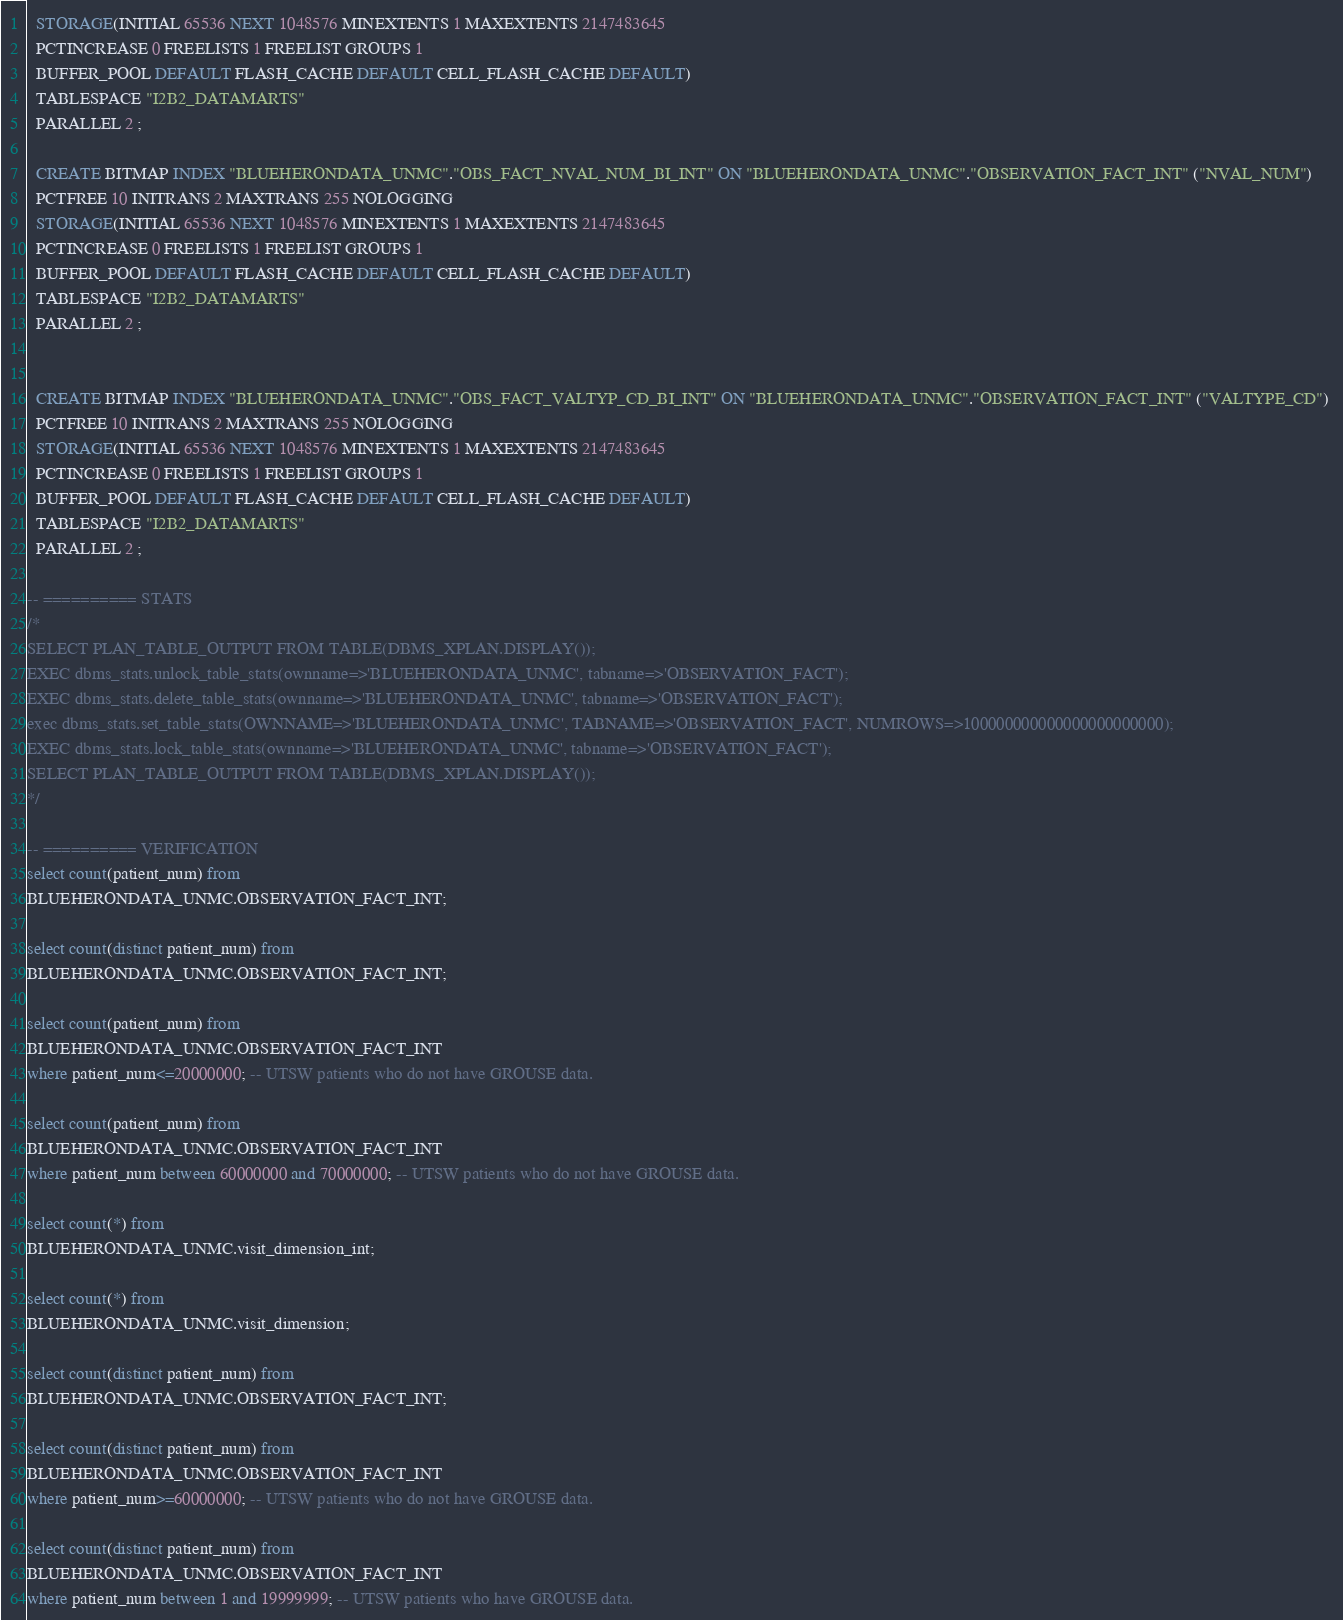Convert code to text. <code><loc_0><loc_0><loc_500><loc_500><_SQL_>  STORAGE(INITIAL 65536 NEXT 1048576 MINEXTENTS 1 MAXEXTENTS 2147483645
  PCTINCREASE 0 FREELISTS 1 FREELIST GROUPS 1
  BUFFER_POOL DEFAULT FLASH_CACHE DEFAULT CELL_FLASH_CACHE DEFAULT)
  TABLESPACE "I2B2_DATAMARTS" 
  PARALLEL 2 ;

  CREATE BITMAP INDEX "BLUEHERONDATA_UNMC"."OBS_FACT_NVAL_NUM_BI_INT" ON "BLUEHERONDATA_UNMC"."OBSERVATION_FACT_INT" ("NVAL_NUM") 
  PCTFREE 10 INITRANS 2 MAXTRANS 255 NOLOGGING 
  STORAGE(INITIAL 65536 NEXT 1048576 MINEXTENTS 1 MAXEXTENTS 2147483645
  PCTINCREASE 0 FREELISTS 1 FREELIST GROUPS 1
  BUFFER_POOL DEFAULT FLASH_CACHE DEFAULT CELL_FLASH_CACHE DEFAULT)
  TABLESPACE "I2B2_DATAMARTS" 
  PARALLEL 2 ;


  CREATE BITMAP INDEX "BLUEHERONDATA_UNMC"."OBS_FACT_VALTYP_CD_BI_INT" ON "BLUEHERONDATA_UNMC"."OBSERVATION_FACT_INT" ("VALTYPE_CD") 
  PCTFREE 10 INITRANS 2 MAXTRANS 255 NOLOGGING 
  STORAGE(INITIAL 65536 NEXT 1048576 MINEXTENTS 1 MAXEXTENTS 2147483645
  PCTINCREASE 0 FREELISTS 1 FREELIST GROUPS 1
  BUFFER_POOL DEFAULT FLASH_CACHE DEFAULT CELL_FLASH_CACHE DEFAULT)
  TABLESPACE "I2B2_DATAMARTS" 
  PARALLEL 2 ;

-- ========== STATS
/*
SELECT PLAN_TABLE_OUTPUT FROM TABLE(DBMS_XPLAN.DISPLAY());
EXEC dbms_stats.unlock_table_stats(ownname=>'BLUEHERONDATA_UNMC', tabname=>'OBSERVATION_FACT');
EXEC dbms_stats.delete_table_stats(ownname=>'BLUEHERONDATA_UNMC', tabname=>'OBSERVATION_FACT');
exec dbms_stats.set_table_stats(OWNNAME=>'BLUEHERONDATA_UNMC', TABNAME=>'OBSERVATION_FACT', NUMROWS=>100000000000000000000000);
EXEC dbms_stats.lock_table_stats(ownname=>'BLUEHERONDATA_UNMC', tabname=>'OBSERVATION_FACT');
SELECT PLAN_TABLE_OUTPUT FROM TABLE(DBMS_XPLAN.DISPLAY());
*/

-- ========== VERIFICATION
select count(patient_num) from 
BLUEHERONDATA_UNMC.OBSERVATION_FACT_INT;

select count(distinct patient_num) from 
BLUEHERONDATA_UNMC.OBSERVATION_FACT_INT;

select count(patient_num) from 
BLUEHERONDATA_UNMC.OBSERVATION_FACT_INT
where patient_num<=20000000; -- UTSW patients who do not have GROUSE data. 

select count(patient_num) from 
BLUEHERONDATA_UNMC.OBSERVATION_FACT_INT
where patient_num between 60000000 and 70000000; -- UTSW patients who do not have GROUSE data. 

select count(*) from 
BLUEHERONDATA_UNMC.visit_dimension_int;

select count(*) from 
BLUEHERONDATA_UNMC.visit_dimension;

select count(distinct patient_num) from 
BLUEHERONDATA_UNMC.OBSERVATION_FACT_INT;

select count(distinct patient_num) from 
BLUEHERONDATA_UNMC.OBSERVATION_FACT_INT
where patient_num>=60000000; -- UTSW patients who do not have GROUSE data. 

select count(distinct patient_num) from 
BLUEHERONDATA_UNMC.OBSERVATION_FACT_INT
where patient_num between 1 and 19999999; -- UTSW patients who have GROUSE data. </code> 